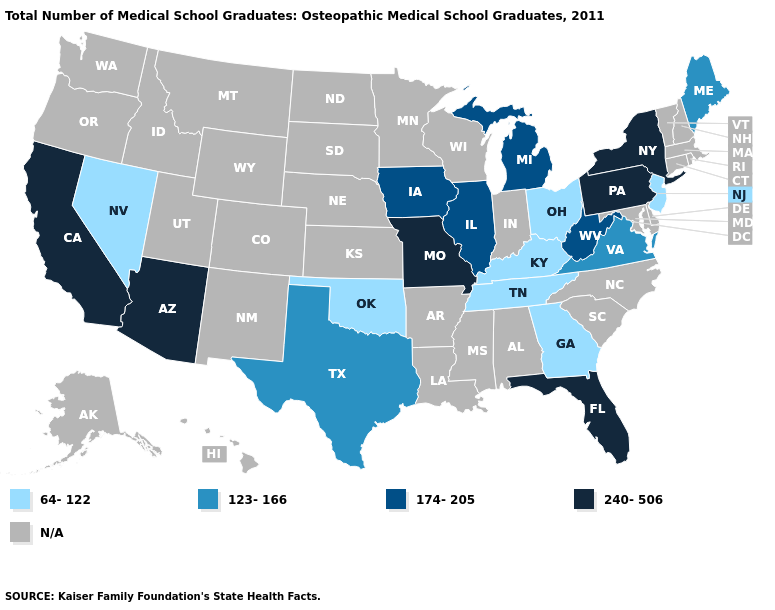What is the value of Alabama?
Answer briefly. N/A. What is the highest value in the USA?
Give a very brief answer. 240-506. Among the states that border New Mexico , which have the lowest value?
Be succinct. Oklahoma. What is the value of South Carolina?
Answer briefly. N/A. Name the states that have a value in the range 64-122?
Quick response, please. Georgia, Kentucky, Nevada, New Jersey, Ohio, Oklahoma, Tennessee. Name the states that have a value in the range 240-506?
Answer briefly. Arizona, California, Florida, Missouri, New York, Pennsylvania. Which states hav the highest value in the MidWest?
Concise answer only. Missouri. What is the lowest value in the USA?
Write a very short answer. 64-122. What is the highest value in the MidWest ?
Short answer required. 240-506. What is the highest value in states that border Arkansas?
Be succinct. 240-506. Among the states that border South Dakota , which have the lowest value?
Write a very short answer. Iowa. Name the states that have a value in the range 174-205?
Write a very short answer. Illinois, Iowa, Michigan, West Virginia. Name the states that have a value in the range 123-166?
Answer briefly. Maine, Texas, Virginia. Among the states that border Illinois , which have the lowest value?
Be succinct. Kentucky. 